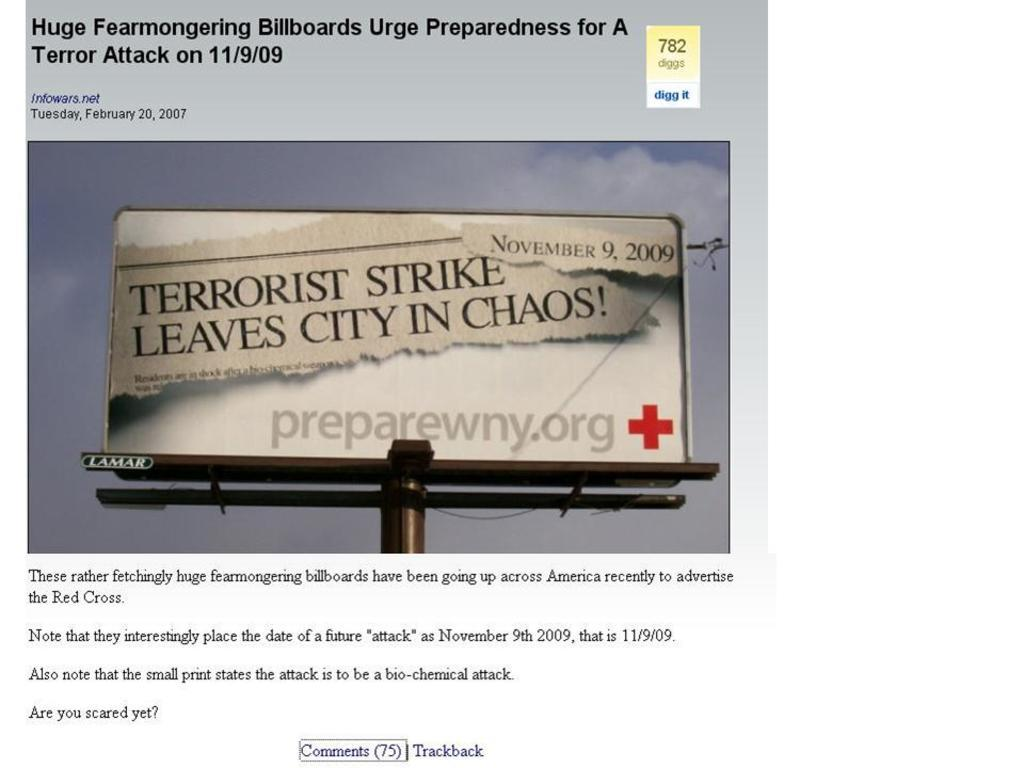<image>
Describe the image concisely. billboards urge preparedness for a terrorist attack held on 11/9/09 